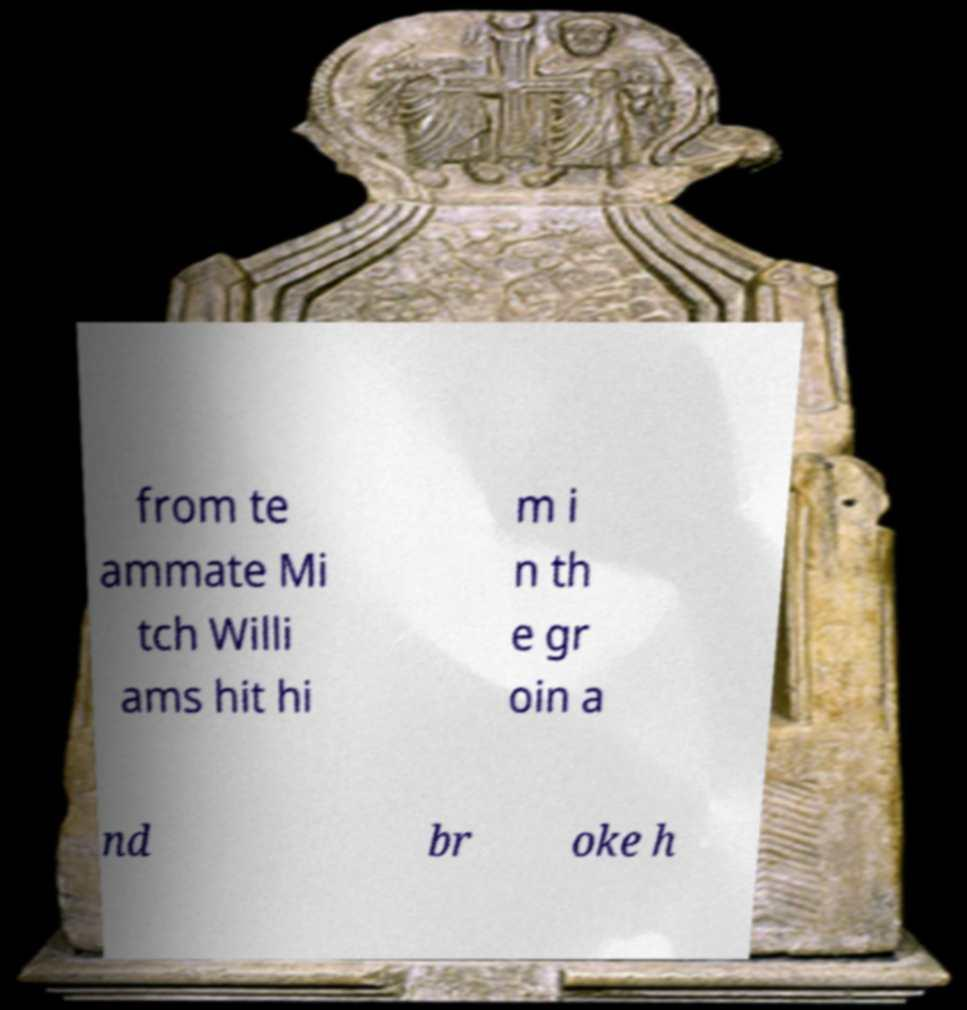Please identify and transcribe the text found in this image. from te ammate Mi tch Willi ams hit hi m i n th e gr oin a nd br oke h 